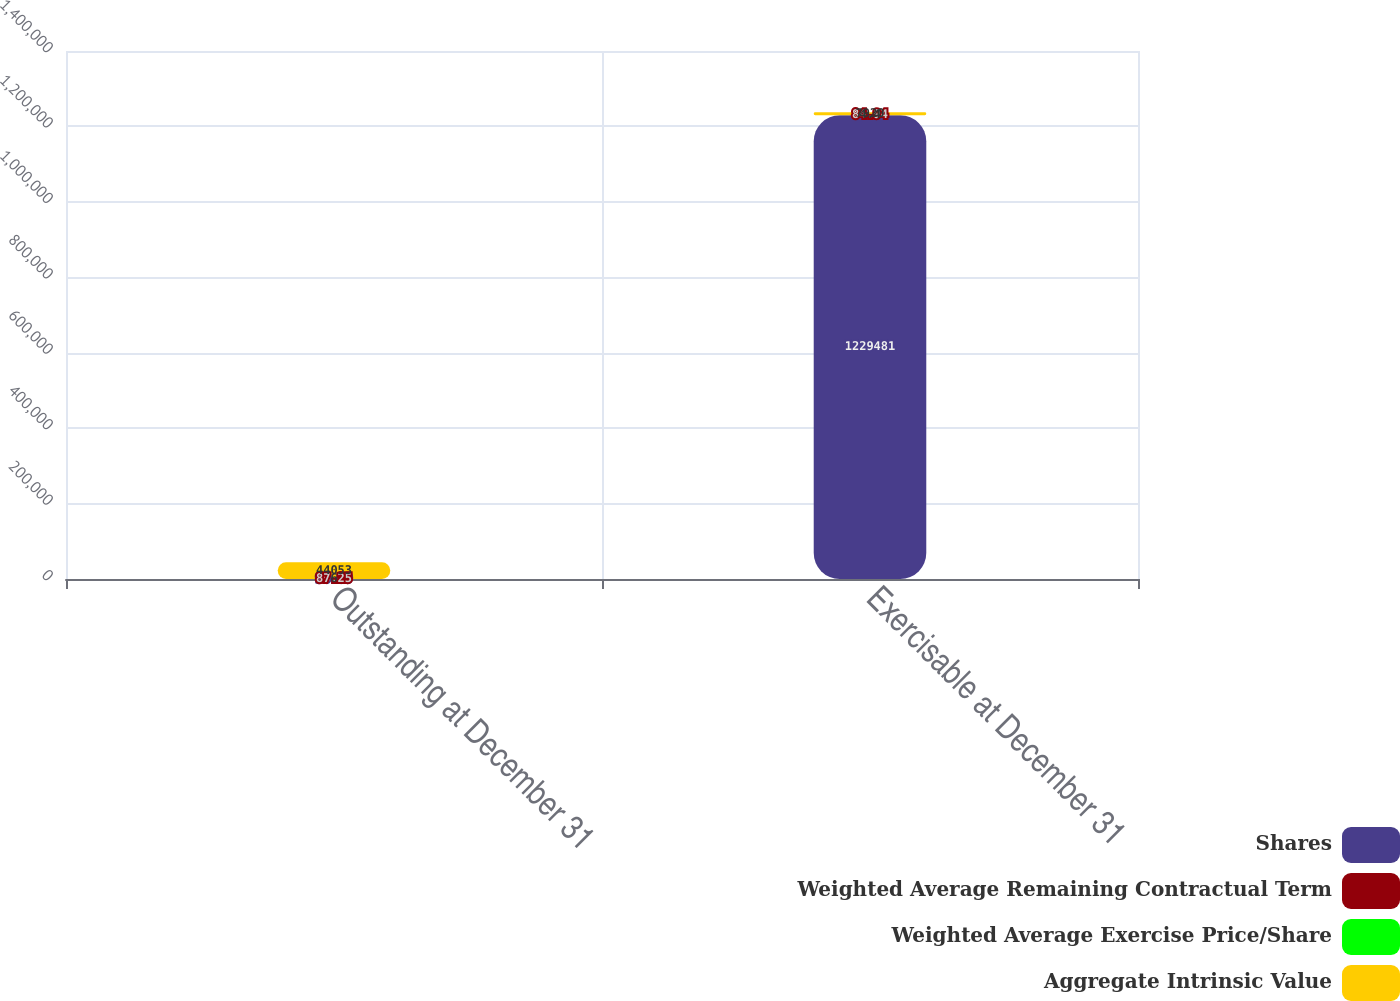Convert chart to OTSL. <chart><loc_0><loc_0><loc_500><loc_500><stacked_bar_chart><ecel><fcel>Outstanding at December 31<fcel>Exercisable at December 31<nl><fcel>Shares<fcel>90.09<fcel>1.22948e+06<nl><fcel>Weighted Average Remaining Contractual Term<fcel>87.25<fcel>84.94<nl><fcel>Weighted Average Exercise Price/Share<fcel>6<fcel>4.4<nl><fcel>Aggregate Intrinsic Value<fcel>44053<fcel>7920<nl></chart> 